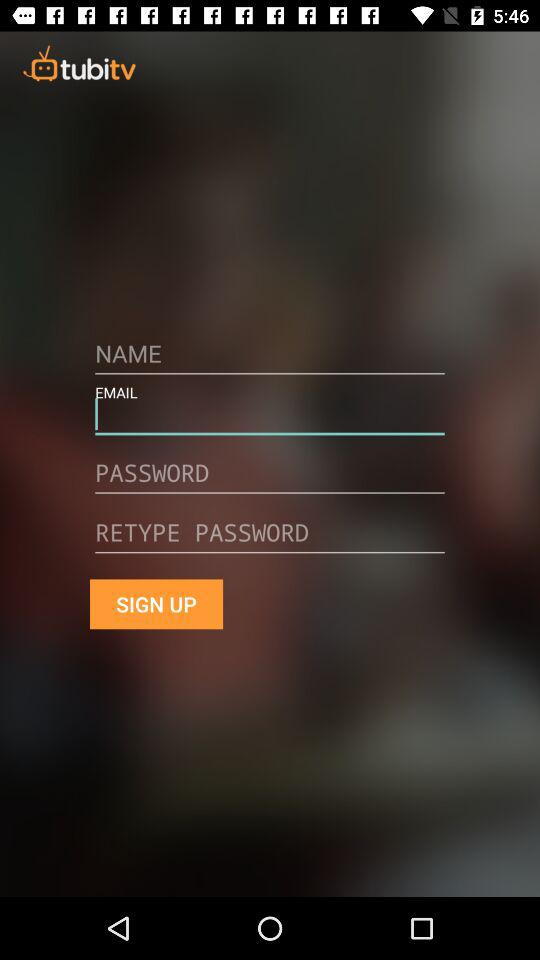What is the application name? The application name is "tubitv". 